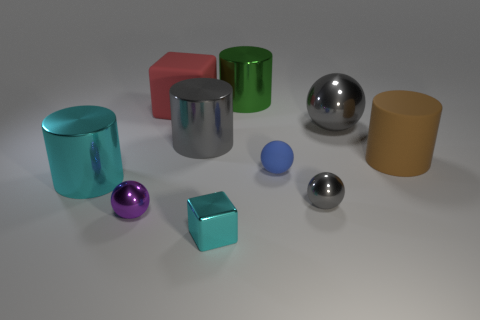The blue sphere has what size?
Make the answer very short. Small. What shape is the object that is the same color as the tiny cube?
Keep it short and to the point. Cylinder. What number of cylinders are small purple objects or small gray objects?
Keep it short and to the point. 0. Are there an equal number of large green metal things that are to the left of the purple metal sphere and big cyan cylinders in front of the tiny gray object?
Provide a short and direct response. Yes. There is a purple metal object that is the same shape as the blue thing; what size is it?
Offer a very short reply. Small. What size is the metallic object that is both in front of the gray metallic cylinder and on the right side of the small cyan metal cube?
Offer a terse response. Small. There is a green thing; are there any big things left of it?
Offer a very short reply. Yes. What number of objects are either large shiny objects on the right side of the small purple metallic object or purple things?
Keep it short and to the point. 4. What number of large cylinders are behind the metal cylinder left of the purple object?
Your answer should be compact. 3. Is the number of blue matte balls left of the green cylinder less than the number of tiny shiny balls that are left of the small cyan block?
Make the answer very short. Yes. 